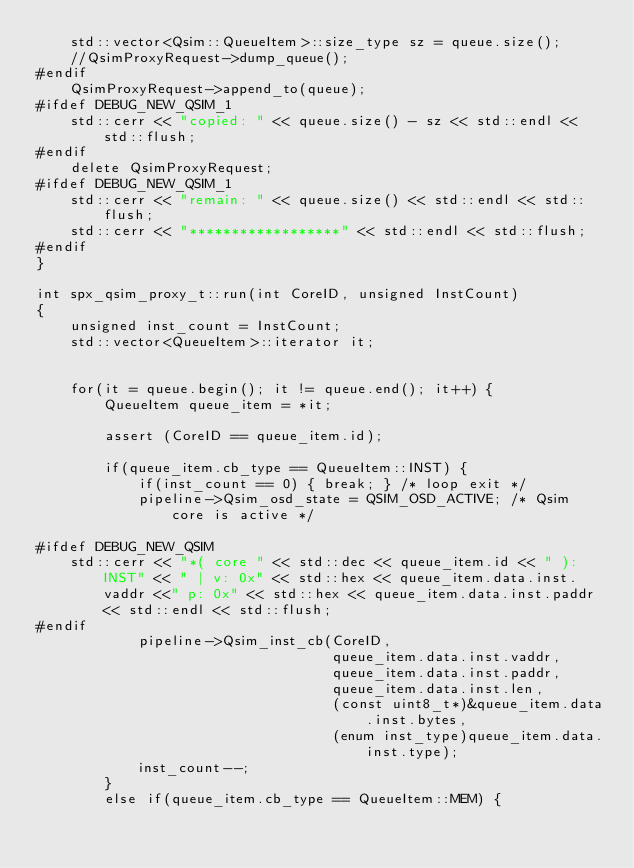<code> <loc_0><loc_0><loc_500><loc_500><_C++_>    std::vector<Qsim::QueueItem>::size_type sz = queue.size();
    //QsimProxyRequest->dump_queue();
#endif
    QsimProxyRequest->append_to(queue);
#ifdef DEBUG_NEW_QSIM_1
    std::cerr << "copied: " << queue.size() - sz << std::endl << std::flush;
#endif
    delete QsimProxyRequest;
#ifdef DEBUG_NEW_QSIM_1
    std::cerr << "remain: " << queue.size() << std::endl << std::flush;
    std::cerr << "******************" << std::endl << std::flush;
#endif
}

int spx_qsim_proxy_t::run(int CoreID, unsigned InstCount)
{
    unsigned inst_count = InstCount;
    std::vector<QueueItem>::iterator it;


    for(it = queue.begin(); it != queue.end(); it++) {
        QueueItem queue_item = *it;

        assert (CoreID == queue_item.id);

        if(queue_item.cb_type == QueueItem::INST) {
            if(inst_count == 0) { break; } /* loop exit */
            pipeline->Qsim_osd_state = QSIM_OSD_ACTIVE; /* Qsim core is active */

#ifdef DEBUG_NEW_QSIM
    std::cerr << "*( core " << std::dec << queue_item.id << " ): INST" << " | v: 0x" << std::hex << queue_item.data.inst.vaddr <<" p: 0x" << std::hex << queue_item.data.inst.paddr << std::endl << std::flush;
#endif
            pipeline->Qsim_inst_cb(CoreID,
                                   queue_item.data.inst.vaddr,
                                   queue_item.data.inst.paddr,
                                   queue_item.data.inst.len,
                                   (const uint8_t*)&queue_item.data.inst.bytes,
                                   (enum inst_type)queue_item.data.inst.type);
            inst_count--;
        }
        else if(queue_item.cb_type == QueueItem::MEM) {</code> 